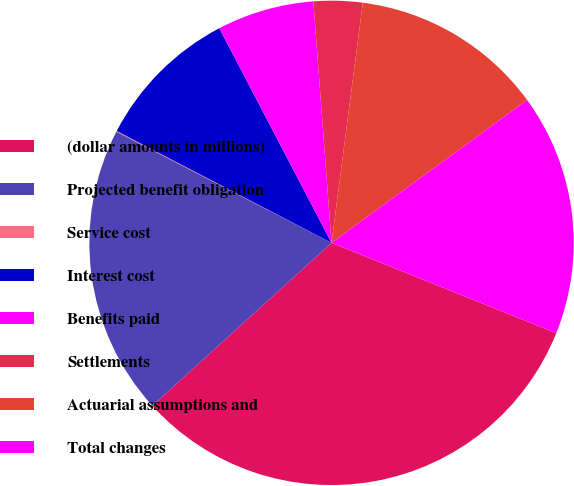Convert chart to OTSL. <chart><loc_0><loc_0><loc_500><loc_500><pie_chart><fcel>(dollar amounts in millions)<fcel>Projected benefit obligation<fcel>Service cost<fcel>Interest cost<fcel>Benefits paid<fcel>Settlements<fcel>Actuarial assumptions and<fcel>Total changes<nl><fcel>32.18%<fcel>19.33%<fcel>0.05%<fcel>9.69%<fcel>6.47%<fcel>3.26%<fcel>12.9%<fcel>16.12%<nl></chart> 